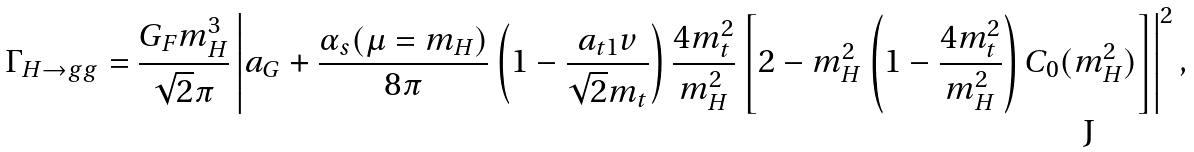<formula> <loc_0><loc_0><loc_500><loc_500>& \Gamma _ { H \to g g } = \frac { G _ { F } m _ { H } ^ { 3 } } { \sqrt { 2 } \pi } \left | a _ { G } + \frac { \alpha _ { s } ( \mu = m _ { H } ) } { 8 \pi } \left ( 1 - \frac { a _ { t 1 } v } { \sqrt { 2 } m _ { t } } \right ) \frac { 4 m _ { t } ^ { 2 } } { m _ { H } ^ { 2 } } \left [ 2 - m _ { H } ^ { 2 } \left ( 1 - \frac { 4 m _ { t } ^ { 2 } } { m _ { H } ^ { 2 } } \right ) C _ { 0 } ( m _ { H } ^ { 2 } ) \right ] \right | ^ { 2 } ,</formula> 